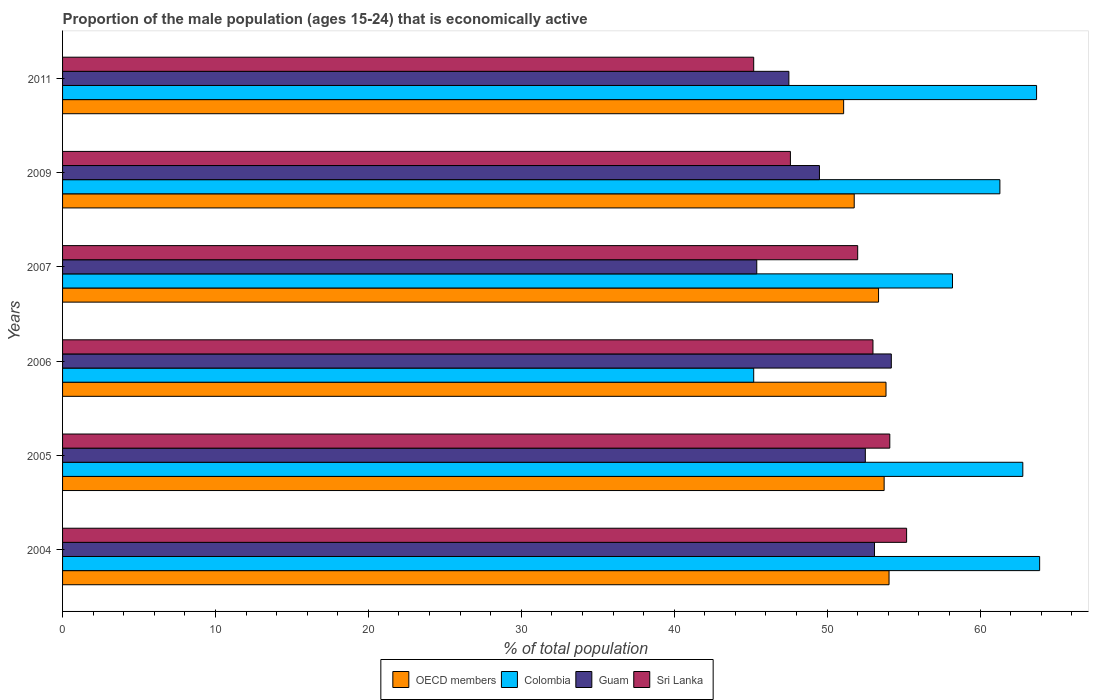How many different coloured bars are there?
Keep it short and to the point. 4. Are the number of bars on each tick of the Y-axis equal?
Your answer should be very brief. Yes. How many bars are there on the 6th tick from the top?
Your answer should be very brief. 4. How many bars are there on the 3rd tick from the bottom?
Give a very brief answer. 4. In how many cases, is the number of bars for a given year not equal to the number of legend labels?
Provide a succinct answer. 0. What is the proportion of the male population that is economically active in Sri Lanka in 2009?
Provide a succinct answer. 47.6. Across all years, what is the maximum proportion of the male population that is economically active in Sri Lanka?
Offer a very short reply. 55.2. Across all years, what is the minimum proportion of the male population that is economically active in Guam?
Provide a succinct answer. 45.4. In which year was the proportion of the male population that is economically active in Sri Lanka maximum?
Ensure brevity in your answer.  2004. What is the total proportion of the male population that is economically active in OECD members in the graph?
Your response must be concise. 317.86. What is the difference between the proportion of the male population that is economically active in OECD members in 2005 and the proportion of the male population that is economically active in Sri Lanka in 2009?
Make the answer very short. 6.13. What is the average proportion of the male population that is economically active in Guam per year?
Your answer should be very brief. 50.37. In the year 2011, what is the difference between the proportion of the male population that is economically active in Sri Lanka and proportion of the male population that is economically active in Guam?
Offer a very short reply. -2.3. In how many years, is the proportion of the male population that is economically active in Sri Lanka greater than 40 %?
Your answer should be compact. 6. What is the ratio of the proportion of the male population that is economically active in OECD members in 2005 to that in 2011?
Your answer should be compact. 1.05. Is the proportion of the male population that is economically active in OECD members in 2006 less than that in 2007?
Offer a terse response. No. What is the difference between the highest and the second highest proportion of the male population that is economically active in Guam?
Provide a succinct answer. 1.1. What is the difference between the highest and the lowest proportion of the male population that is economically active in Colombia?
Make the answer very short. 18.7. In how many years, is the proportion of the male population that is economically active in Colombia greater than the average proportion of the male population that is economically active in Colombia taken over all years?
Provide a succinct answer. 4. What does the 3rd bar from the bottom in 2005 represents?
Offer a very short reply. Guam. Are all the bars in the graph horizontal?
Make the answer very short. Yes. What is the difference between two consecutive major ticks on the X-axis?
Provide a short and direct response. 10. Are the values on the major ticks of X-axis written in scientific E-notation?
Offer a very short reply. No. Does the graph contain any zero values?
Ensure brevity in your answer.  No. Where does the legend appear in the graph?
Give a very brief answer. Bottom center. What is the title of the graph?
Give a very brief answer. Proportion of the male population (ages 15-24) that is economically active. Does "Latin America(developing only)" appear as one of the legend labels in the graph?
Provide a short and direct response. No. What is the label or title of the X-axis?
Offer a terse response. % of total population. What is the label or title of the Y-axis?
Provide a succinct answer. Years. What is the % of total population in OECD members in 2004?
Make the answer very short. 54.05. What is the % of total population of Colombia in 2004?
Make the answer very short. 63.9. What is the % of total population in Guam in 2004?
Offer a very short reply. 53.1. What is the % of total population in Sri Lanka in 2004?
Keep it short and to the point. 55.2. What is the % of total population in OECD members in 2005?
Your response must be concise. 53.73. What is the % of total population in Colombia in 2005?
Ensure brevity in your answer.  62.8. What is the % of total population of Guam in 2005?
Ensure brevity in your answer.  52.5. What is the % of total population of Sri Lanka in 2005?
Provide a succinct answer. 54.1. What is the % of total population in OECD members in 2006?
Offer a terse response. 53.85. What is the % of total population in Colombia in 2006?
Your answer should be compact. 45.2. What is the % of total population in Guam in 2006?
Offer a terse response. 54.2. What is the % of total population of OECD members in 2007?
Offer a terse response. 53.36. What is the % of total population in Colombia in 2007?
Provide a succinct answer. 58.2. What is the % of total population in Guam in 2007?
Offer a very short reply. 45.4. What is the % of total population in OECD members in 2009?
Provide a short and direct response. 51.77. What is the % of total population of Colombia in 2009?
Offer a terse response. 61.3. What is the % of total population of Guam in 2009?
Your response must be concise. 49.5. What is the % of total population in Sri Lanka in 2009?
Ensure brevity in your answer.  47.6. What is the % of total population of OECD members in 2011?
Your answer should be very brief. 51.08. What is the % of total population of Colombia in 2011?
Offer a terse response. 63.7. What is the % of total population in Guam in 2011?
Give a very brief answer. 47.5. What is the % of total population in Sri Lanka in 2011?
Your response must be concise. 45.2. Across all years, what is the maximum % of total population in OECD members?
Offer a terse response. 54.05. Across all years, what is the maximum % of total population of Colombia?
Your answer should be compact. 63.9. Across all years, what is the maximum % of total population in Guam?
Make the answer very short. 54.2. Across all years, what is the maximum % of total population in Sri Lanka?
Offer a very short reply. 55.2. Across all years, what is the minimum % of total population of OECD members?
Your response must be concise. 51.08. Across all years, what is the minimum % of total population of Colombia?
Provide a succinct answer. 45.2. Across all years, what is the minimum % of total population of Guam?
Offer a very short reply. 45.4. Across all years, what is the minimum % of total population of Sri Lanka?
Ensure brevity in your answer.  45.2. What is the total % of total population in OECD members in the graph?
Provide a short and direct response. 317.86. What is the total % of total population of Colombia in the graph?
Offer a terse response. 355.1. What is the total % of total population of Guam in the graph?
Give a very brief answer. 302.2. What is the total % of total population in Sri Lanka in the graph?
Ensure brevity in your answer.  307.1. What is the difference between the % of total population in OECD members in 2004 and that in 2005?
Ensure brevity in your answer.  0.32. What is the difference between the % of total population of Sri Lanka in 2004 and that in 2005?
Provide a short and direct response. 1.1. What is the difference between the % of total population of OECD members in 2004 and that in 2006?
Offer a terse response. 0.2. What is the difference between the % of total population in Colombia in 2004 and that in 2006?
Your response must be concise. 18.7. What is the difference between the % of total population of Guam in 2004 and that in 2006?
Make the answer very short. -1.1. What is the difference between the % of total population in OECD members in 2004 and that in 2007?
Make the answer very short. 0.69. What is the difference between the % of total population of OECD members in 2004 and that in 2009?
Your answer should be compact. 2.28. What is the difference between the % of total population of Colombia in 2004 and that in 2009?
Keep it short and to the point. 2.6. What is the difference between the % of total population in Guam in 2004 and that in 2009?
Provide a succinct answer. 3.6. What is the difference between the % of total population in OECD members in 2004 and that in 2011?
Offer a very short reply. 2.97. What is the difference between the % of total population of Colombia in 2004 and that in 2011?
Your answer should be compact. 0.2. What is the difference between the % of total population of Sri Lanka in 2004 and that in 2011?
Make the answer very short. 10. What is the difference between the % of total population of OECD members in 2005 and that in 2006?
Your answer should be compact. -0.12. What is the difference between the % of total population in Guam in 2005 and that in 2006?
Your answer should be very brief. -1.7. What is the difference between the % of total population in OECD members in 2005 and that in 2007?
Your response must be concise. 0.37. What is the difference between the % of total population in OECD members in 2005 and that in 2009?
Make the answer very short. 1.96. What is the difference between the % of total population of Colombia in 2005 and that in 2009?
Provide a succinct answer. 1.5. What is the difference between the % of total population in Sri Lanka in 2005 and that in 2009?
Your answer should be very brief. 6.5. What is the difference between the % of total population in OECD members in 2005 and that in 2011?
Provide a short and direct response. 2.65. What is the difference between the % of total population of Colombia in 2005 and that in 2011?
Your answer should be compact. -0.9. What is the difference between the % of total population in Sri Lanka in 2005 and that in 2011?
Give a very brief answer. 8.9. What is the difference between the % of total population in OECD members in 2006 and that in 2007?
Give a very brief answer. 0.49. What is the difference between the % of total population of Colombia in 2006 and that in 2007?
Keep it short and to the point. -13. What is the difference between the % of total population in Sri Lanka in 2006 and that in 2007?
Your answer should be compact. 1. What is the difference between the % of total population in OECD members in 2006 and that in 2009?
Offer a very short reply. 2.08. What is the difference between the % of total population in Colombia in 2006 and that in 2009?
Keep it short and to the point. -16.1. What is the difference between the % of total population in OECD members in 2006 and that in 2011?
Your response must be concise. 2.77. What is the difference between the % of total population in Colombia in 2006 and that in 2011?
Provide a succinct answer. -18.5. What is the difference between the % of total population of Guam in 2006 and that in 2011?
Your answer should be very brief. 6.7. What is the difference between the % of total population in OECD members in 2007 and that in 2009?
Your response must be concise. 1.59. What is the difference between the % of total population in Guam in 2007 and that in 2009?
Keep it short and to the point. -4.1. What is the difference between the % of total population of OECD members in 2007 and that in 2011?
Provide a short and direct response. 2.28. What is the difference between the % of total population in OECD members in 2009 and that in 2011?
Your answer should be very brief. 0.69. What is the difference between the % of total population of Sri Lanka in 2009 and that in 2011?
Offer a terse response. 2.4. What is the difference between the % of total population in OECD members in 2004 and the % of total population in Colombia in 2005?
Your response must be concise. -8.75. What is the difference between the % of total population in OECD members in 2004 and the % of total population in Guam in 2005?
Your response must be concise. 1.55. What is the difference between the % of total population of OECD members in 2004 and the % of total population of Sri Lanka in 2005?
Your answer should be very brief. -0.05. What is the difference between the % of total population in Colombia in 2004 and the % of total population in Guam in 2005?
Make the answer very short. 11.4. What is the difference between the % of total population of Colombia in 2004 and the % of total population of Sri Lanka in 2005?
Make the answer very short. 9.8. What is the difference between the % of total population of OECD members in 2004 and the % of total population of Colombia in 2006?
Offer a very short reply. 8.85. What is the difference between the % of total population of OECD members in 2004 and the % of total population of Guam in 2006?
Provide a short and direct response. -0.15. What is the difference between the % of total population of OECD members in 2004 and the % of total population of Sri Lanka in 2006?
Provide a short and direct response. 1.05. What is the difference between the % of total population in Guam in 2004 and the % of total population in Sri Lanka in 2006?
Ensure brevity in your answer.  0.1. What is the difference between the % of total population in OECD members in 2004 and the % of total population in Colombia in 2007?
Provide a short and direct response. -4.15. What is the difference between the % of total population of OECD members in 2004 and the % of total population of Guam in 2007?
Offer a terse response. 8.65. What is the difference between the % of total population in OECD members in 2004 and the % of total population in Sri Lanka in 2007?
Your answer should be very brief. 2.05. What is the difference between the % of total population of OECD members in 2004 and the % of total population of Colombia in 2009?
Make the answer very short. -7.25. What is the difference between the % of total population in OECD members in 2004 and the % of total population in Guam in 2009?
Your response must be concise. 4.55. What is the difference between the % of total population of OECD members in 2004 and the % of total population of Sri Lanka in 2009?
Your answer should be very brief. 6.45. What is the difference between the % of total population of Colombia in 2004 and the % of total population of Guam in 2009?
Make the answer very short. 14.4. What is the difference between the % of total population of OECD members in 2004 and the % of total population of Colombia in 2011?
Keep it short and to the point. -9.65. What is the difference between the % of total population of OECD members in 2004 and the % of total population of Guam in 2011?
Ensure brevity in your answer.  6.55. What is the difference between the % of total population in OECD members in 2004 and the % of total population in Sri Lanka in 2011?
Provide a short and direct response. 8.85. What is the difference between the % of total population in Colombia in 2004 and the % of total population in Guam in 2011?
Your response must be concise. 16.4. What is the difference between the % of total population of Guam in 2004 and the % of total population of Sri Lanka in 2011?
Keep it short and to the point. 7.9. What is the difference between the % of total population of OECD members in 2005 and the % of total population of Colombia in 2006?
Your response must be concise. 8.53. What is the difference between the % of total population in OECD members in 2005 and the % of total population in Guam in 2006?
Your answer should be very brief. -0.47. What is the difference between the % of total population of OECD members in 2005 and the % of total population of Sri Lanka in 2006?
Offer a terse response. 0.73. What is the difference between the % of total population in Guam in 2005 and the % of total population in Sri Lanka in 2006?
Your response must be concise. -0.5. What is the difference between the % of total population of OECD members in 2005 and the % of total population of Colombia in 2007?
Provide a short and direct response. -4.47. What is the difference between the % of total population of OECD members in 2005 and the % of total population of Guam in 2007?
Offer a terse response. 8.33. What is the difference between the % of total population of OECD members in 2005 and the % of total population of Sri Lanka in 2007?
Keep it short and to the point. 1.73. What is the difference between the % of total population in Colombia in 2005 and the % of total population in Guam in 2007?
Make the answer very short. 17.4. What is the difference between the % of total population in OECD members in 2005 and the % of total population in Colombia in 2009?
Your response must be concise. -7.57. What is the difference between the % of total population of OECD members in 2005 and the % of total population of Guam in 2009?
Provide a short and direct response. 4.23. What is the difference between the % of total population in OECD members in 2005 and the % of total population in Sri Lanka in 2009?
Offer a very short reply. 6.13. What is the difference between the % of total population of Colombia in 2005 and the % of total population of Guam in 2009?
Your response must be concise. 13.3. What is the difference between the % of total population in Colombia in 2005 and the % of total population in Sri Lanka in 2009?
Give a very brief answer. 15.2. What is the difference between the % of total population of Guam in 2005 and the % of total population of Sri Lanka in 2009?
Your answer should be very brief. 4.9. What is the difference between the % of total population in OECD members in 2005 and the % of total population in Colombia in 2011?
Ensure brevity in your answer.  -9.97. What is the difference between the % of total population of OECD members in 2005 and the % of total population of Guam in 2011?
Offer a terse response. 6.23. What is the difference between the % of total population of OECD members in 2005 and the % of total population of Sri Lanka in 2011?
Provide a succinct answer. 8.53. What is the difference between the % of total population of OECD members in 2006 and the % of total population of Colombia in 2007?
Provide a succinct answer. -4.35. What is the difference between the % of total population in OECD members in 2006 and the % of total population in Guam in 2007?
Your answer should be very brief. 8.45. What is the difference between the % of total population in OECD members in 2006 and the % of total population in Sri Lanka in 2007?
Give a very brief answer. 1.85. What is the difference between the % of total population of Colombia in 2006 and the % of total population of Guam in 2007?
Offer a terse response. -0.2. What is the difference between the % of total population in Guam in 2006 and the % of total population in Sri Lanka in 2007?
Make the answer very short. 2.2. What is the difference between the % of total population of OECD members in 2006 and the % of total population of Colombia in 2009?
Your answer should be compact. -7.45. What is the difference between the % of total population of OECD members in 2006 and the % of total population of Guam in 2009?
Ensure brevity in your answer.  4.35. What is the difference between the % of total population in OECD members in 2006 and the % of total population in Sri Lanka in 2009?
Provide a succinct answer. 6.25. What is the difference between the % of total population in Colombia in 2006 and the % of total population in Sri Lanka in 2009?
Offer a terse response. -2.4. What is the difference between the % of total population of OECD members in 2006 and the % of total population of Colombia in 2011?
Offer a terse response. -9.85. What is the difference between the % of total population of OECD members in 2006 and the % of total population of Guam in 2011?
Provide a short and direct response. 6.35. What is the difference between the % of total population in OECD members in 2006 and the % of total population in Sri Lanka in 2011?
Offer a terse response. 8.65. What is the difference between the % of total population in Colombia in 2006 and the % of total population in Guam in 2011?
Your response must be concise. -2.3. What is the difference between the % of total population in OECD members in 2007 and the % of total population in Colombia in 2009?
Make the answer very short. -7.94. What is the difference between the % of total population of OECD members in 2007 and the % of total population of Guam in 2009?
Give a very brief answer. 3.86. What is the difference between the % of total population in OECD members in 2007 and the % of total population in Sri Lanka in 2009?
Ensure brevity in your answer.  5.76. What is the difference between the % of total population in OECD members in 2007 and the % of total population in Colombia in 2011?
Offer a very short reply. -10.34. What is the difference between the % of total population in OECD members in 2007 and the % of total population in Guam in 2011?
Give a very brief answer. 5.86. What is the difference between the % of total population of OECD members in 2007 and the % of total population of Sri Lanka in 2011?
Give a very brief answer. 8.16. What is the difference between the % of total population in Guam in 2007 and the % of total population in Sri Lanka in 2011?
Offer a terse response. 0.2. What is the difference between the % of total population in OECD members in 2009 and the % of total population in Colombia in 2011?
Offer a very short reply. -11.93. What is the difference between the % of total population of OECD members in 2009 and the % of total population of Guam in 2011?
Offer a terse response. 4.27. What is the difference between the % of total population in OECD members in 2009 and the % of total population in Sri Lanka in 2011?
Your response must be concise. 6.57. What is the difference between the % of total population of Colombia in 2009 and the % of total population of Guam in 2011?
Your answer should be very brief. 13.8. What is the difference between the % of total population of Guam in 2009 and the % of total population of Sri Lanka in 2011?
Offer a very short reply. 4.3. What is the average % of total population of OECD members per year?
Give a very brief answer. 52.98. What is the average % of total population of Colombia per year?
Make the answer very short. 59.18. What is the average % of total population of Guam per year?
Ensure brevity in your answer.  50.37. What is the average % of total population in Sri Lanka per year?
Ensure brevity in your answer.  51.18. In the year 2004, what is the difference between the % of total population of OECD members and % of total population of Colombia?
Give a very brief answer. -9.85. In the year 2004, what is the difference between the % of total population of OECD members and % of total population of Guam?
Provide a short and direct response. 0.95. In the year 2004, what is the difference between the % of total population in OECD members and % of total population in Sri Lanka?
Provide a succinct answer. -1.15. In the year 2004, what is the difference between the % of total population in Colombia and % of total population in Sri Lanka?
Your answer should be very brief. 8.7. In the year 2005, what is the difference between the % of total population of OECD members and % of total population of Colombia?
Provide a succinct answer. -9.07. In the year 2005, what is the difference between the % of total population of OECD members and % of total population of Guam?
Provide a succinct answer. 1.23. In the year 2005, what is the difference between the % of total population in OECD members and % of total population in Sri Lanka?
Provide a short and direct response. -0.37. In the year 2005, what is the difference between the % of total population of Colombia and % of total population of Sri Lanka?
Give a very brief answer. 8.7. In the year 2006, what is the difference between the % of total population in OECD members and % of total population in Colombia?
Keep it short and to the point. 8.65. In the year 2006, what is the difference between the % of total population of OECD members and % of total population of Guam?
Ensure brevity in your answer.  -0.35. In the year 2006, what is the difference between the % of total population in OECD members and % of total population in Sri Lanka?
Provide a short and direct response. 0.85. In the year 2006, what is the difference between the % of total population in Colombia and % of total population in Guam?
Your response must be concise. -9. In the year 2007, what is the difference between the % of total population of OECD members and % of total population of Colombia?
Provide a short and direct response. -4.84. In the year 2007, what is the difference between the % of total population of OECD members and % of total population of Guam?
Keep it short and to the point. 7.96. In the year 2007, what is the difference between the % of total population in OECD members and % of total population in Sri Lanka?
Provide a short and direct response. 1.36. In the year 2007, what is the difference between the % of total population of Guam and % of total population of Sri Lanka?
Provide a short and direct response. -6.6. In the year 2009, what is the difference between the % of total population in OECD members and % of total population in Colombia?
Your answer should be very brief. -9.53. In the year 2009, what is the difference between the % of total population in OECD members and % of total population in Guam?
Your answer should be compact. 2.27. In the year 2009, what is the difference between the % of total population of OECD members and % of total population of Sri Lanka?
Make the answer very short. 4.17. In the year 2009, what is the difference between the % of total population of Colombia and % of total population of Guam?
Ensure brevity in your answer.  11.8. In the year 2009, what is the difference between the % of total population of Colombia and % of total population of Sri Lanka?
Keep it short and to the point. 13.7. In the year 2009, what is the difference between the % of total population of Guam and % of total population of Sri Lanka?
Your answer should be very brief. 1.9. In the year 2011, what is the difference between the % of total population in OECD members and % of total population in Colombia?
Offer a terse response. -12.62. In the year 2011, what is the difference between the % of total population of OECD members and % of total population of Guam?
Make the answer very short. 3.58. In the year 2011, what is the difference between the % of total population of OECD members and % of total population of Sri Lanka?
Ensure brevity in your answer.  5.88. In the year 2011, what is the difference between the % of total population of Colombia and % of total population of Sri Lanka?
Your answer should be very brief. 18.5. In the year 2011, what is the difference between the % of total population in Guam and % of total population in Sri Lanka?
Keep it short and to the point. 2.3. What is the ratio of the % of total population of OECD members in 2004 to that in 2005?
Your answer should be very brief. 1.01. What is the ratio of the % of total population of Colombia in 2004 to that in 2005?
Your answer should be very brief. 1.02. What is the ratio of the % of total population of Guam in 2004 to that in 2005?
Provide a succinct answer. 1.01. What is the ratio of the % of total population of Sri Lanka in 2004 to that in 2005?
Your response must be concise. 1.02. What is the ratio of the % of total population of OECD members in 2004 to that in 2006?
Offer a terse response. 1. What is the ratio of the % of total population of Colombia in 2004 to that in 2006?
Your answer should be compact. 1.41. What is the ratio of the % of total population of Guam in 2004 to that in 2006?
Provide a short and direct response. 0.98. What is the ratio of the % of total population in Sri Lanka in 2004 to that in 2006?
Ensure brevity in your answer.  1.04. What is the ratio of the % of total population in OECD members in 2004 to that in 2007?
Your answer should be compact. 1.01. What is the ratio of the % of total population in Colombia in 2004 to that in 2007?
Your answer should be very brief. 1.1. What is the ratio of the % of total population in Guam in 2004 to that in 2007?
Keep it short and to the point. 1.17. What is the ratio of the % of total population in Sri Lanka in 2004 to that in 2007?
Offer a terse response. 1.06. What is the ratio of the % of total population in OECD members in 2004 to that in 2009?
Offer a very short reply. 1.04. What is the ratio of the % of total population of Colombia in 2004 to that in 2009?
Keep it short and to the point. 1.04. What is the ratio of the % of total population of Guam in 2004 to that in 2009?
Give a very brief answer. 1.07. What is the ratio of the % of total population of Sri Lanka in 2004 to that in 2009?
Provide a succinct answer. 1.16. What is the ratio of the % of total population of OECD members in 2004 to that in 2011?
Provide a short and direct response. 1.06. What is the ratio of the % of total population in Colombia in 2004 to that in 2011?
Give a very brief answer. 1. What is the ratio of the % of total population in Guam in 2004 to that in 2011?
Provide a short and direct response. 1.12. What is the ratio of the % of total population of Sri Lanka in 2004 to that in 2011?
Offer a terse response. 1.22. What is the ratio of the % of total population of OECD members in 2005 to that in 2006?
Ensure brevity in your answer.  1. What is the ratio of the % of total population of Colombia in 2005 to that in 2006?
Ensure brevity in your answer.  1.39. What is the ratio of the % of total population of Guam in 2005 to that in 2006?
Provide a short and direct response. 0.97. What is the ratio of the % of total population of Sri Lanka in 2005 to that in 2006?
Provide a succinct answer. 1.02. What is the ratio of the % of total population of Colombia in 2005 to that in 2007?
Offer a terse response. 1.08. What is the ratio of the % of total population in Guam in 2005 to that in 2007?
Give a very brief answer. 1.16. What is the ratio of the % of total population of Sri Lanka in 2005 to that in 2007?
Your answer should be compact. 1.04. What is the ratio of the % of total population of OECD members in 2005 to that in 2009?
Give a very brief answer. 1.04. What is the ratio of the % of total population in Colombia in 2005 to that in 2009?
Keep it short and to the point. 1.02. What is the ratio of the % of total population in Guam in 2005 to that in 2009?
Ensure brevity in your answer.  1.06. What is the ratio of the % of total population of Sri Lanka in 2005 to that in 2009?
Provide a short and direct response. 1.14. What is the ratio of the % of total population of OECD members in 2005 to that in 2011?
Offer a very short reply. 1.05. What is the ratio of the % of total population in Colombia in 2005 to that in 2011?
Provide a short and direct response. 0.99. What is the ratio of the % of total population of Guam in 2005 to that in 2011?
Your response must be concise. 1.11. What is the ratio of the % of total population in Sri Lanka in 2005 to that in 2011?
Offer a terse response. 1.2. What is the ratio of the % of total population in OECD members in 2006 to that in 2007?
Ensure brevity in your answer.  1.01. What is the ratio of the % of total population of Colombia in 2006 to that in 2007?
Your answer should be very brief. 0.78. What is the ratio of the % of total population in Guam in 2006 to that in 2007?
Your answer should be very brief. 1.19. What is the ratio of the % of total population of Sri Lanka in 2006 to that in 2007?
Keep it short and to the point. 1.02. What is the ratio of the % of total population in OECD members in 2006 to that in 2009?
Keep it short and to the point. 1.04. What is the ratio of the % of total population of Colombia in 2006 to that in 2009?
Provide a short and direct response. 0.74. What is the ratio of the % of total population in Guam in 2006 to that in 2009?
Give a very brief answer. 1.09. What is the ratio of the % of total population in Sri Lanka in 2006 to that in 2009?
Offer a terse response. 1.11. What is the ratio of the % of total population in OECD members in 2006 to that in 2011?
Make the answer very short. 1.05. What is the ratio of the % of total population in Colombia in 2006 to that in 2011?
Offer a very short reply. 0.71. What is the ratio of the % of total population in Guam in 2006 to that in 2011?
Offer a very short reply. 1.14. What is the ratio of the % of total population of Sri Lanka in 2006 to that in 2011?
Offer a terse response. 1.17. What is the ratio of the % of total population of OECD members in 2007 to that in 2009?
Make the answer very short. 1.03. What is the ratio of the % of total population in Colombia in 2007 to that in 2009?
Your answer should be compact. 0.95. What is the ratio of the % of total population of Guam in 2007 to that in 2009?
Give a very brief answer. 0.92. What is the ratio of the % of total population in Sri Lanka in 2007 to that in 2009?
Your answer should be compact. 1.09. What is the ratio of the % of total population of OECD members in 2007 to that in 2011?
Ensure brevity in your answer.  1.04. What is the ratio of the % of total population in Colombia in 2007 to that in 2011?
Your response must be concise. 0.91. What is the ratio of the % of total population of Guam in 2007 to that in 2011?
Your answer should be compact. 0.96. What is the ratio of the % of total population of Sri Lanka in 2007 to that in 2011?
Provide a short and direct response. 1.15. What is the ratio of the % of total population of OECD members in 2009 to that in 2011?
Ensure brevity in your answer.  1.01. What is the ratio of the % of total population in Colombia in 2009 to that in 2011?
Your answer should be very brief. 0.96. What is the ratio of the % of total population of Guam in 2009 to that in 2011?
Your answer should be very brief. 1.04. What is the ratio of the % of total population of Sri Lanka in 2009 to that in 2011?
Offer a terse response. 1.05. What is the difference between the highest and the second highest % of total population in OECD members?
Make the answer very short. 0.2. What is the difference between the highest and the second highest % of total population in Colombia?
Make the answer very short. 0.2. What is the difference between the highest and the second highest % of total population of Guam?
Provide a short and direct response. 1.1. What is the difference between the highest and the lowest % of total population of OECD members?
Give a very brief answer. 2.97. What is the difference between the highest and the lowest % of total population of Guam?
Provide a succinct answer. 8.8. 